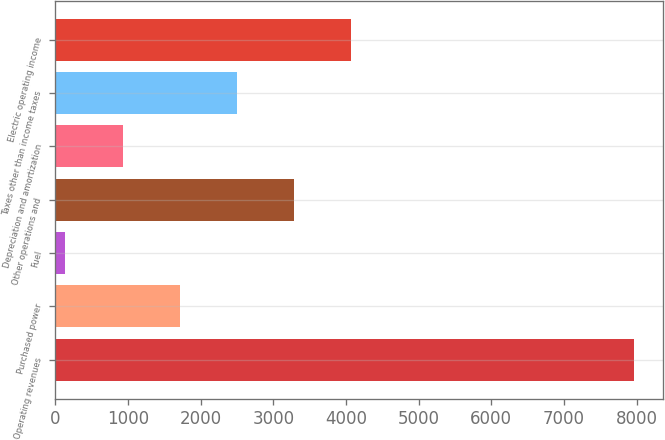Convert chart to OTSL. <chart><loc_0><loc_0><loc_500><loc_500><bar_chart><fcel>Operating revenues<fcel>Purchased power<fcel>Fuel<fcel>Other operations and<fcel>Depreciation and amortization<fcel>Taxes other than income taxes<fcel>Electric operating income<nl><fcel>7972<fcel>1709.5<fcel>127<fcel>3278.5<fcel>925<fcel>2494<fcel>4063<nl></chart> 